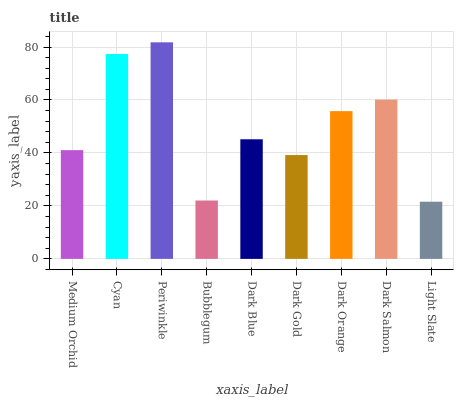Is Light Slate the minimum?
Answer yes or no. Yes. Is Periwinkle the maximum?
Answer yes or no. Yes. Is Cyan the minimum?
Answer yes or no. No. Is Cyan the maximum?
Answer yes or no. No. Is Cyan greater than Medium Orchid?
Answer yes or no. Yes. Is Medium Orchid less than Cyan?
Answer yes or no. Yes. Is Medium Orchid greater than Cyan?
Answer yes or no. No. Is Cyan less than Medium Orchid?
Answer yes or no. No. Is Dark Blue the high median?
Answer yes or no. Yes. Is Dark Blue the low median?
Answer yes or no. Yes. Is Dark Gold the high median?
Answer yes or no. No. Is Dark Gold the low median?
Answer yes or no. No. 